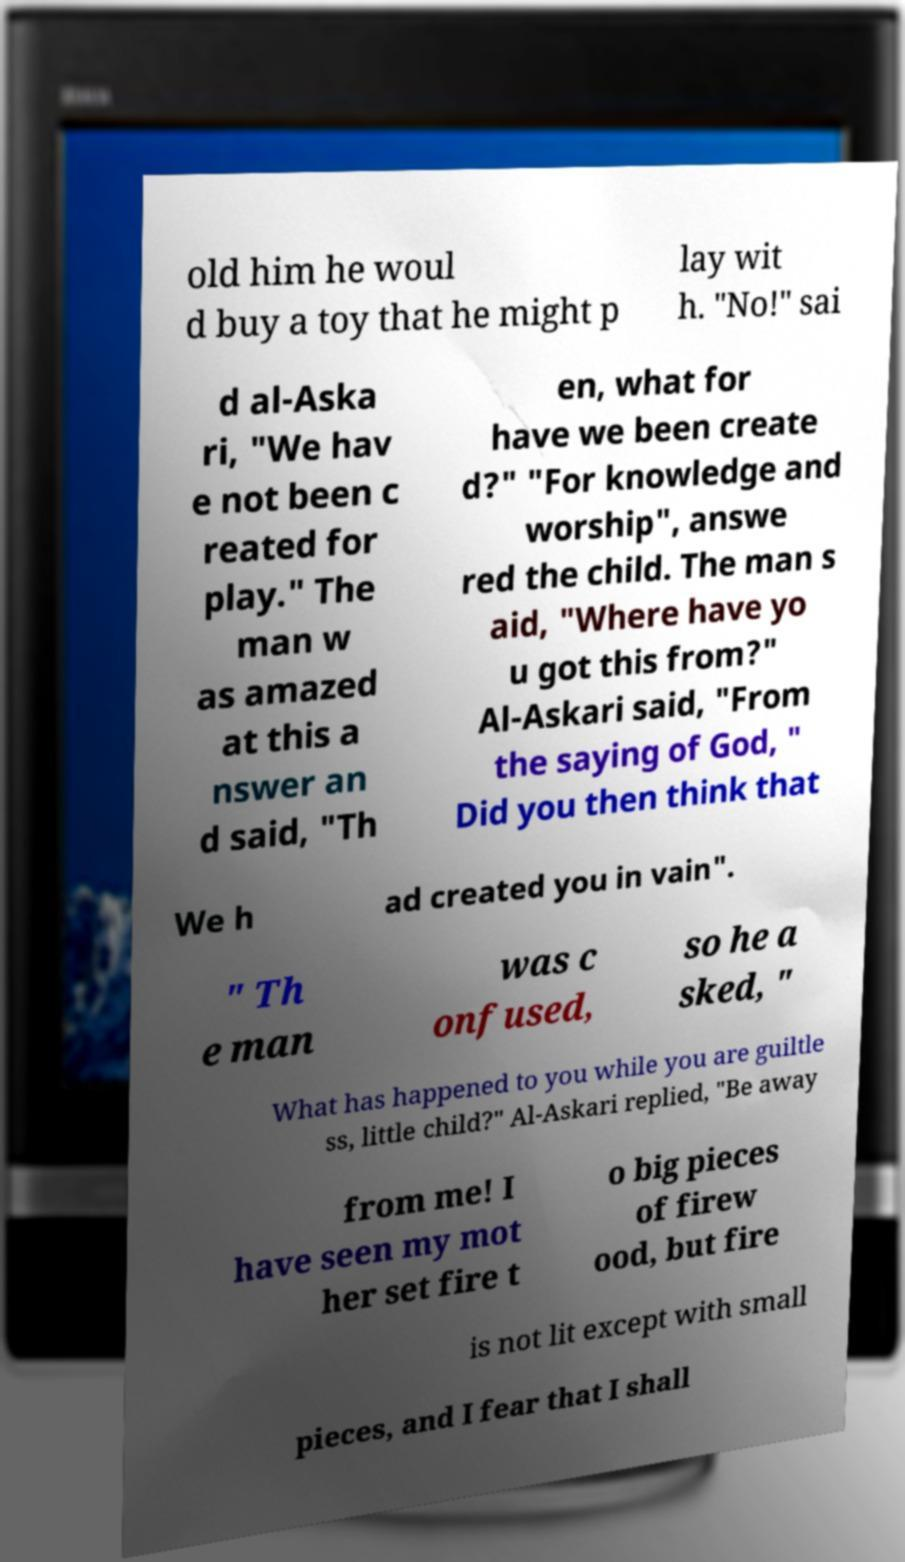Could you extract and type out the text from this image? old him he woul d buy a toy that he might p lay wit h. "No!" sai d al-Aska ri, "We hav e not been c reated for play." The man w as amazed at this a nswer an d said, "Th en, what for have we been create d?" "For knowledge and worship", answe red the child. The man s aid, "Where have yo u got this from?" Al-Askari said, "From the saying of God, " Did you then think that We h ad created you in vain". " Th e man was c onfused, so he a sked, " What has happened to you while you are guiltle ss, little child?" Al-Askari replied, "Be away from me! I have seen my mot her set fire t o big pieces of firew ood, but fire is not lit except with small pieces, and I fear that I shall 